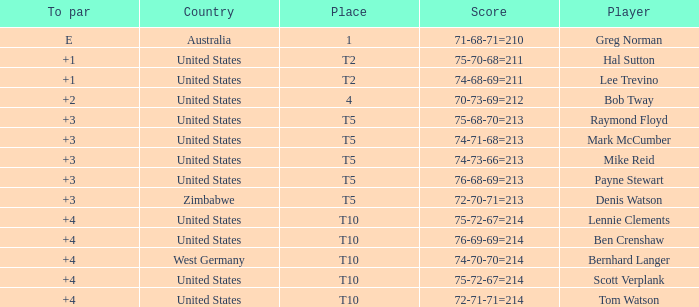Who is the participant with a +3 to par and a 74-71-68=213 score? Mark McCumber. 